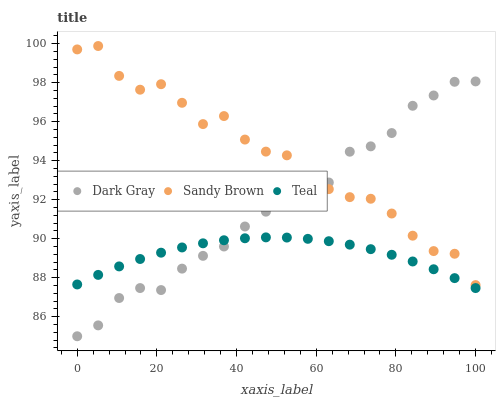Does Teal have the minimum area under the curve?
Answer yes or no. Yes. Does Sandy Brown have the maximum area under the curve?
Answer yes or no. Yes. Does Sandy Brown have the minimum area under the curve?
Answer yes or no. No. Does Teal have the maximum area under the curve?
Answer yes or no. No. Is Teal the smoothest?
Answer yes or no. Yes. Is Sandy Brown the roughest?
Answer yes or no. Yes. Is Sandy Brown the smoothest?
Answer yes or no. No. Is Teal the roughest?
Answer yes or no. No. Does Dark Gray have the lowest value?
Answer yes or no. Yes. Does Teal have the lowest value?
Answer yes or no. No. Does Sandy Brown have the highest value?
Answer yes or no. Yes. Does Teal have the highest value?
Answer yes or no. No. Is Teal less than Sandy Brown?
Answer yes or no. Yes. Is Sandy Brown greater than Teal?
Answer yes or no. Yes. Does Sandy Brown intersect Dark Gray?
Answer yes or no. Yes. Is Sandy Brown less than Dark Gray?
Answer yes or no. No. Is Sandy Brown greater than Dark Gray?
Answer yes or no. No. Does Teal intersect Sandy Brown?
Answer yes or no. No. 